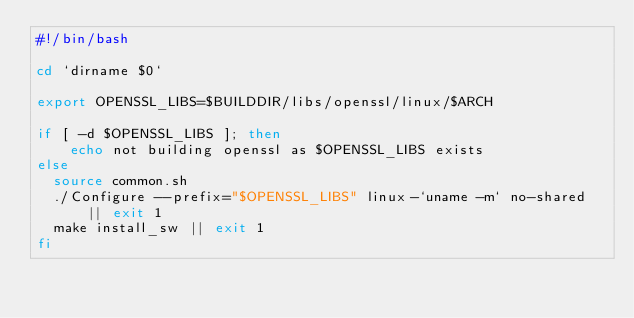Convert code to text. <code><loc_0><loc_0><loc_500><loc_500><_Bash_>#!/bin/bash

cd `dirname $0`

export OPENSSL_LIBS=$BUILDDIR/libs/openssl/linux/$ARCH

if [ -d $OPENSSL_LIBS ]; then
    echo not building openssl as $OPENSSL_LIBS exists
else
  source common.sh
  ./Configure --prefix="$OPENSSL_LIBS" linux-`uname -m` no-shared || exit 1
  make install_sw || exit 1
fi



</code> 